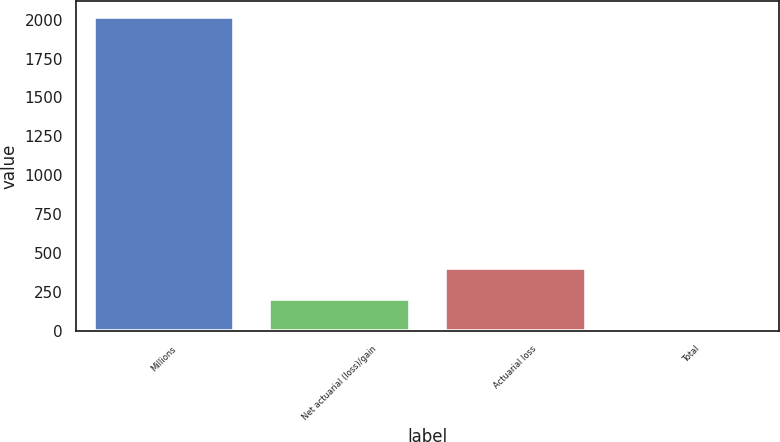Convert chart to OTSL. <chart><loc_0><loc_0><loc_500><loc_500><bar_chart><fcel>Millions<fcel>Net actuarial (loss)/gain<fcel>Actuarial loss<fcel>Total<nl><fcel>2017<fcel>205.3<fcel>406.6<fcel>4<nl></chart> 